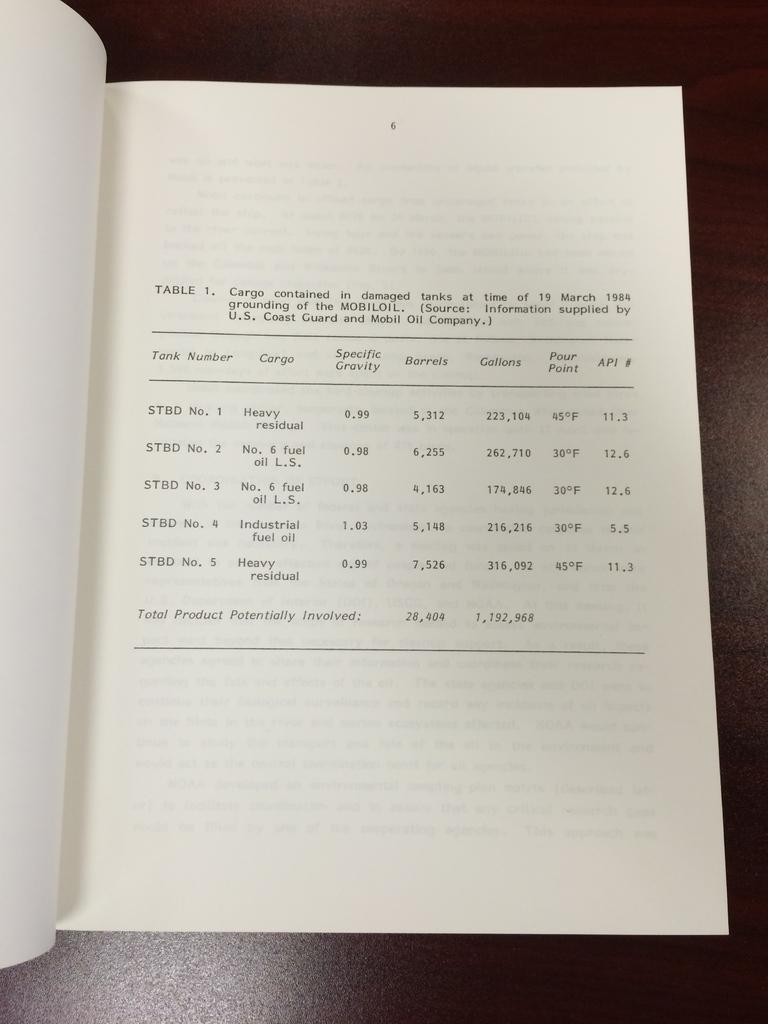<image>
Relay a brief, clear account of the picture shown. A pamphlet with the tank number in it 